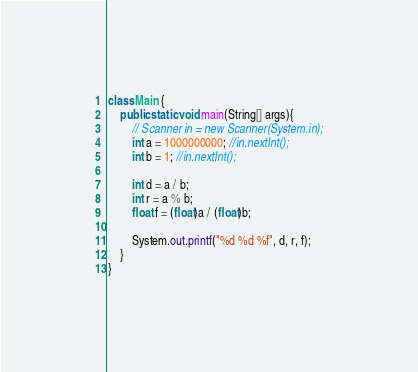Convert code to text. <code><loc_0><loc_0><loc_500><loc_500><_Java_>
class Main {
    public static void main(String[] args){
    	// Scanner in = new Scanner(System.in);
		int a = 1000000000; //in.nextInt();
		int b = 1; //in.nextInt();

		int d = a / b;
		int r = a % b;
		float f = (float)a / (float)b;

    	System.out.printf("%d %d %f", d, r, f);
    }
}</code> 